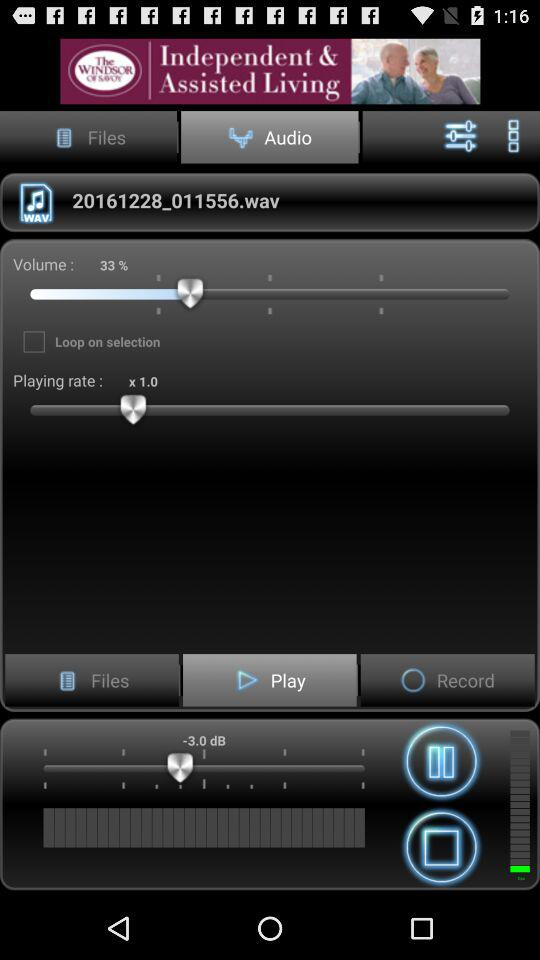How much more volume is there when the volume is set to 100% compared to 33%?
Answer the question using a single word or phrase. 67% 